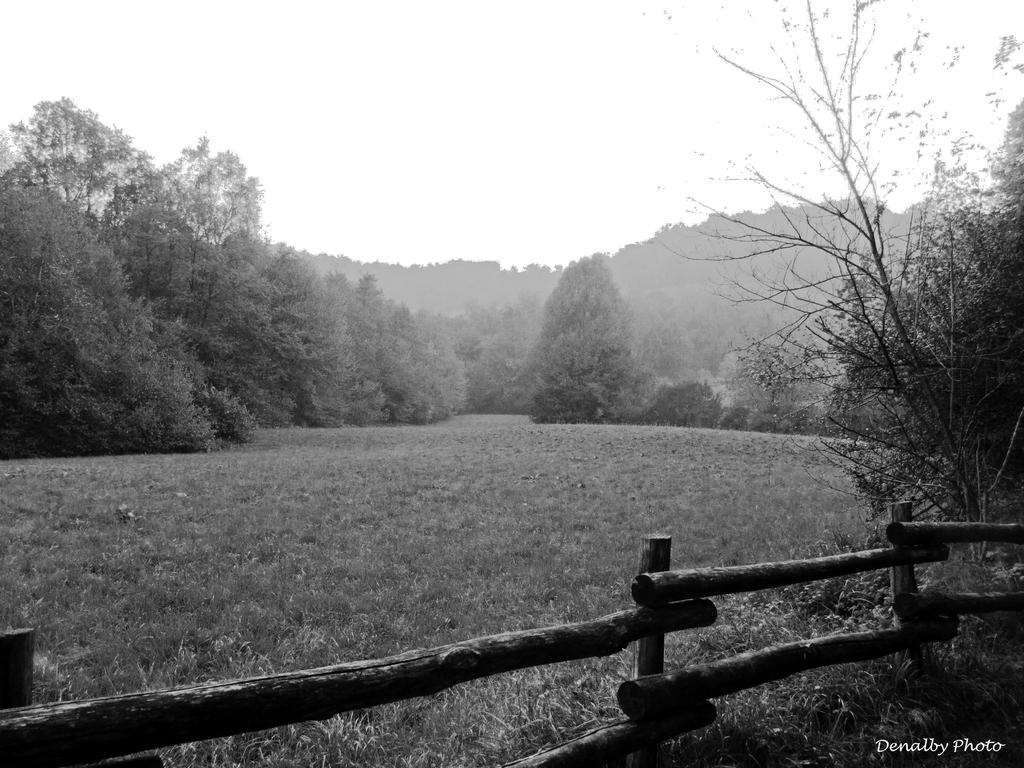What is the color scheme of the photograph? The photograph has a black and white view. What type of landscape can be seen in the front of the image? There is a grass lawn in the front of the image. What kind of fencing is present in the front of the image? There is bamboo fencing railing in the front of the image. What can be seen behind the grass lawn and bamboo fencing railing? There are trees visible behind the grass lawn and bamboo fencing railing. What type of stew is being cooked in the image? There is no stew present in the image; it is a photograph of a landscape with a grass lawn, bamboo fencing railing, and trees. Can you see any stars in the image? There are no stars visible in the image, as it is a photograph of a landscape with a grass lawn, bamboo fencing railing, and trees. 